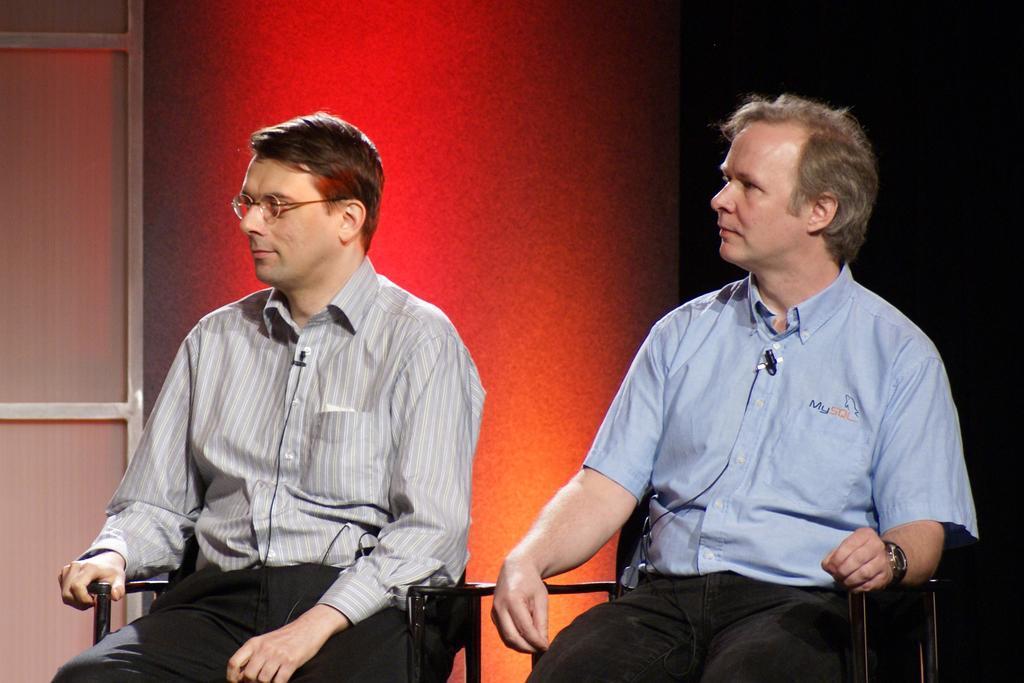Could you give a brief overview of what you see in this image? In this image in the foreground there are two persons who are sitting on chairs, and in the background there is a wall. On the left side there is a door. 